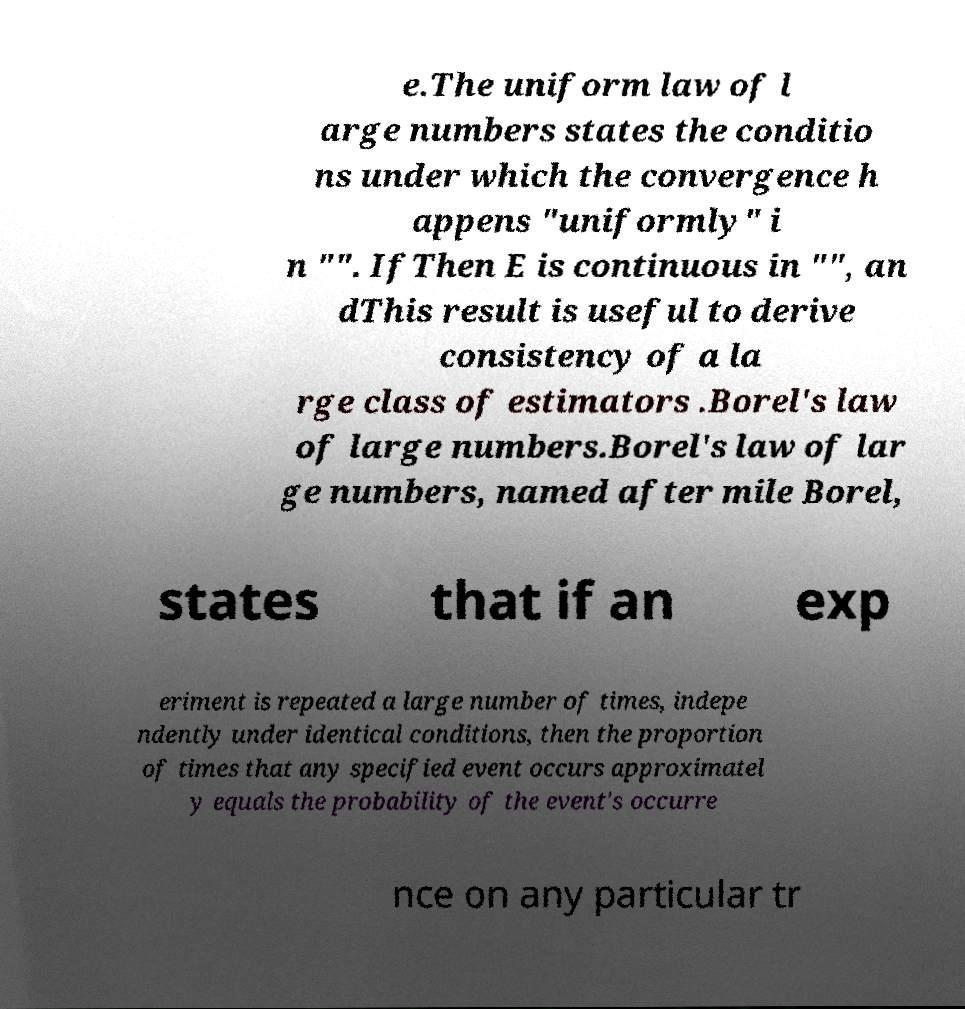I need the written content from this picture converted into text. Can you do that? e.The uniform law of l arge numbers states the conditio ns under which the convergence h appens "uniformly" i n "". IfThen E is continuous in "", an dThis result is useful to derive consistency of a la rge class of estimators .Borel's law of large numbers.Borel's law of lar ge numbers, named after mile Borel, states that if an exp eriment is repeated a large number of times, indepe ndently under identical conditions, then the proportion of times that any specified event occurs approximatel y equals the probability of the event's occurre nce on any particular tr 